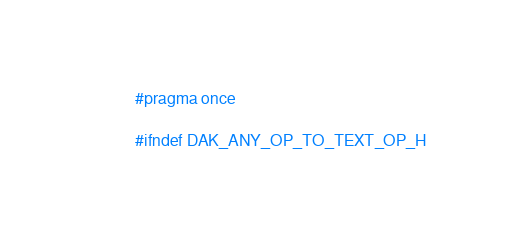Convert code to text. <code><loc_0><loc_0><loc_500><loc_500><_C_>#pragma once

#ifndef DAK_ANY_OP_TO_TEXT_OP_H</code> 